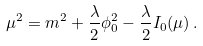Convert formula to latex. <formula><loc_0><loc_0><loc_500><loc_500>\mu ^ { 2 } = m ^ { 2 } + { \frac { \lambda } { 2 } } \phi _ { 0 } ^ { 2 } - { \frac { \lambda } { 2 } } I _ { 0 } ( \mu ) \, .</formula> 